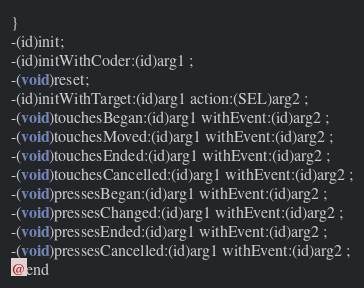<code> <loc_0><loc_0><loc_500><loc_500><_C_>
}
-(id)init;
-(id)initWithCoder:(id)arg1 ;
-(void)reset;
-(id)initWithTarget:(id)arg1 action:(SEL)arg2 ;
-(void)touchesBegan:(id)arg1 withEvent:(id)arg2 ;
-(void)touchesMoved:(id)arg1 withEvent:(id)arg2 ;
-(void)touchesEnded:(id)arg1 withEvent:(id)arg2 ;
-(void)touchesCancelled:(id)arg1 withEvent:(id)arg2 ;
-(void)pressesBegan:(id)arg1 withEvent:(id)arg2 ;
-(void)pressesChanged:(id)arg1 withEvent:(id)arg2 ;
-(void)pressesEnded:(id)arg1 withEvent:(id)arg2 ;
-(void)pressesCancelled:(id)arg1 withEvent:(id)arg2 ;
@end

</code> 